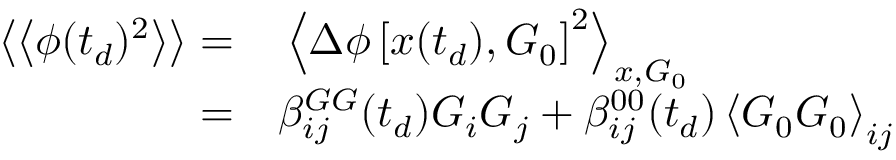<formula> <loc_0><loc_0><loc_500><loc_500>\begin{array} { r l } { \left \langle \left \langle \phi ( t _ { d } ) ^ { 2 } \right \rangle \right \rangle = } & \left \langle \Delta \phi \left [ x ( t _ { d } ) , G _ { 0 } \right ] ^ { 2 } \right \rangle _ { x , G _ { 0 } } } \\ { = } & \beta _ { i j } ^ { G G } ( t _ { d } ) G _ { i } G _ { j } + \beta _ { i j } ^ { 0 0 } ( t _ { d } ) \left \langle G _ { 0 } G _ { 0 } \right \rangle _ { i j } } \end{array}</formula> 